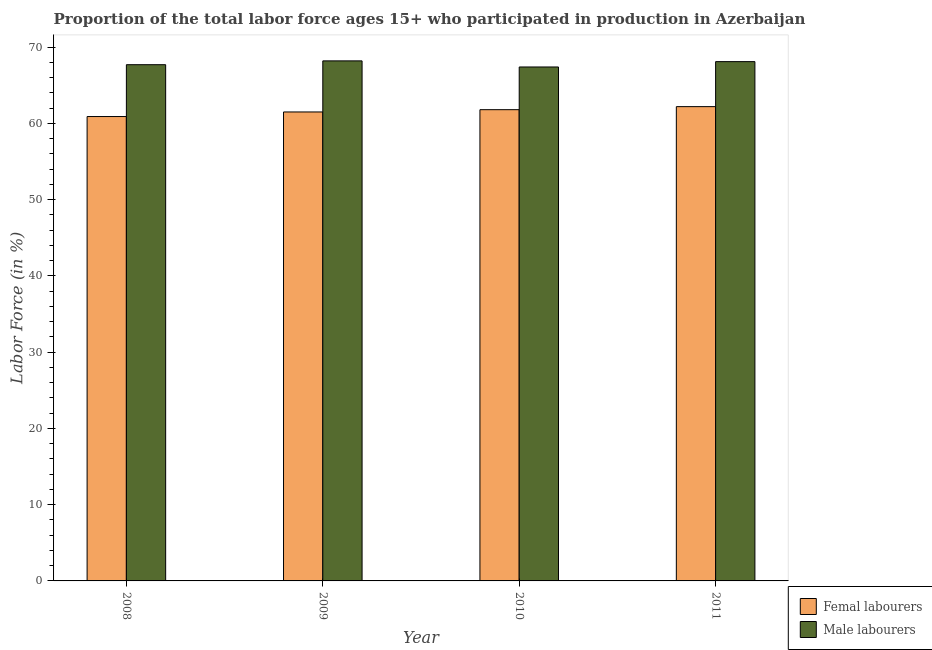How many different coloured bars are there?
Offer a terse response. 2. How many groups of bars are there?
Your response must be concise. 4. Are the number of bars per tick equal to the number of legend labels?
Offer a terse response. Yes. In how many cases, is the number of bars for a given year not equal to the number of legend labels?
Provide a short and direct response. 0. What is the percentage of female labor force in 2010?
Your answer should be very brief. 61.8. Across all years, what is the maximum percentage of male labour force?
Provide a succinct answer. 68.2. Across all years, what is the minimum percentage of female labor force?
Make the answer very short. 60.9. In which year was the percentage of female labor force maximum?
Your answer should be compact. 2011. In which year was the percentage of male labour force minimum?
Your answer should be compact. 2010. What is the total percentage of male labour force in the graph?
Offer a very short reply. 271.4. What is the difference between the percentage of female labor force in 2008 and that in 2009?
Offer a very short reply. -0.6. What is the difference between the percentage of female labor force in 2008 and the percentage of male labour force in 2010?
Your response must be concise. -0.9. What is the average percentage of male labour force per year?
Keep it short and to the point. 67.85. In the year 2011, what is the difference between the percentage of female labor force and percentage of male labour force?
Provide a succinct answer. 0. In how many years, is the percentage of male labour force greater than 12 %?
Ensure brevity in your answer.  4. What is the ratio of the percentage of female labor force in 2010 to that in 2011?
Offer a terse response. 0.99. Is the difference between the percentage of male labour force in 2008 and 2011 greater than the difference between the percentage of female labor force in 2008 and 2011?
Ensure brevity in your answer.  No. What is the difference between the highest and the second highest percentage of female labor force?
Provide a succinct answer. 0.4. What is the difference between the highest and the lowest percentage of male labour force?
Provide a short and direct response. 0.8. In how many years, is the percentage of male labour force greater than the average percentage of male labour force taken over all years?
Ensure brevity in your answer.  2. Is the sum of the percentage of male labour force in 2009 and 2010 greater than the maximum percentage of female labor force across all years?
Your response must be concise. Yes. What does the 2nd bar from the left in 2009 represents?
Ensure brevity in your answer.  Male labourers. What does the 1st bar from the right in 2009 represents?
Give a very brief answer. Male labourers. What is the difference between two consecutive major ticks on the Y-axis?
Provide a short and direct response. 10. Does the graph contain any zero values?
Your answer should be very brief. No. Does the graph contain grids?
Ensure brevity in your answer.  No. How many legend labels are there?
Your answer should be very brief. 2. What is the title of the graph?
Offer a terse response. Proportion of the total labor force ages 15+ who participated in production in Azerbaijan. What is the Labor Force (in %) of Femal labourers in 2008?
Keep it short and to the point. 60.9. What is the Labor Force (in %) in Male labourers in 2008?
Provide a succinct answer. 67.7. What is the Labor Force (in %) in Femal labourers in 2009?
Provide a succinct answer. 61.5. What is the Labor Force (in %) in Male labourers in 2009?
Make the answer very short. 68.2. What is the Labor Force (in %) of Femal labourers in 2010?
Provide a succinct answer. 61.8. What is the Labor Force (in %) in Male labourers in 2010?
Give a very brief answer. 67.4. What is the Labor Force (in %) in Femal labourers in 2011?
Your response must be concise. 62.2. What is the Labor Force (in %) in Male labourers in 2011?
Make the answer very short. 68.1. Across all years, what is the maximum Labor Force (in %) in Femal labourers?
Keep it short and to the point. 62.2. Across all years, what is the maximum Labor Force (in %) of Male labourers?
Your answer should be compact. 68.2. Across all years, what is the minimum Labor Force (in %) in Femal labourers?
Offer a very short reply. 60.9. Across all years, what is the minimum Labor Force (in %) of Male labourers?
Your answer should be very brief. 67.4. What is the total Labor Force (in %) of Femal labourers in the graph?
Offer a very short reply. 246.4. What is the total Labor Force (in %) of Male labourers in the graph?
Make the answer very short. 271.4. What is the difference between the Labor Force (in %) of Male labourers in 2008 and that in 2009?
Make the answer very short. -0.5. What is the difference between the Labor Force (in %) of Femal labourers in 2008 and that in 2010?
Offer a very short reply. -0.9. What is the difference between the Labor Force (in %) in Femal labourers in 2009 and that in 2010?
Your answer should be very brief. -0.3. What is the difference between the Labor Force (in %) in Femal labourers in 2009 and that in 2011?
Ensure brevity in your answer.  -0.7. What is the difference between the Labor Force (in %) in Femal labourers in 2010 and that in 2011?
Your answer should be very brief. -0.4. What is the difference between the Labor Force (in %) of Femal labourers in 2008 and the Labor Force (in %) of Male labourers in 2011?
Provide a succinct answer. -7.2. What is the difference between the Labor Force (in %) in Femal labourers in 2009 and the Labor Force (in %) in Male labourers in 2011?
Offer a very short reply. -6.6. What is the difference between the Labor Force (in %) in Femal labourers in 2010 and the Labor Force (in %) in Male labourers in 2011?
Provide a short and direct response. -6.3. What is the average Labor Force (in %) in Femal labourers per year?
Ensure brevity in your answer.  61.6. What is the average Labor Force (in %) of Male labourers per year?
Offer a very short reply. 67.85. In the year 2009, what is the difference between the Labor Force (in %) in Femal labourers and Labor Force (in %) in Male labourers?
Your answer should be very brief. -6.7. In the year 2010, what is the difference between the Labor Force (in %) in Femal labourers and Labor Force (in %) in Male labourers?
Your answer should be very brief. -5.6. In the year 2011, what is the difference between the Labor Force (in %) in Femal labourers and Labor Force (in %) in Male labourers?
Your answer should be compact. -5.9. What is the ratio of the Labor Force (in %) in Femal labourers in 2008 to that in 2009?
Make the answer very short. 0.99. What is the ratio of the Labor Force (in %) in Femal labourers in 2008 to that in 2010?
Give a very brief answer. 0.99. What is the ratio of the Labor Force (in %) in Male labourers in 2008 to that in 2010?
Offer a very short reply. 1. What is the ratio of the Labor Force (in %) of Femal labourers in 2008 to that in 2011?
Offer a very short reply. 0.98. What is the ratio of the Labor Force (in %) of Male labourers in 2008 to that in 2011?
Provide a short and direct response. 0.99. What is the ratio of the Labor Force (in %) in Femal labourers in 2009 to that in 2010?
Offer a terse response. 1. What is the ratio of the Labor Force (in %) of Male labourers in 2009 to that in 2010?
Give a very brief answer. 1.01. What is the ratio of the Labor Force (in %) of Femal labourers in 2009 to that in 2011?
Your response must be concise. 0.99. What is the ratio of the Labor Force (in %) in Male labourers in 2009 to that in 2011?
Your answer should be compact. 1. What is the ratio of the Labor Force (in %) of Femal labourers in 2010 to that in 2011?
Make the answer very short. 0.99. What is the ratio of the Labor Force (in %) of Male labourers in 2010 to that in 2011?
Your answer should be very brief. 0.99. What is the difference between the highest and the second highest Labor Force (in %) of Male labourers?
Offer a very short reply. 0.1. 